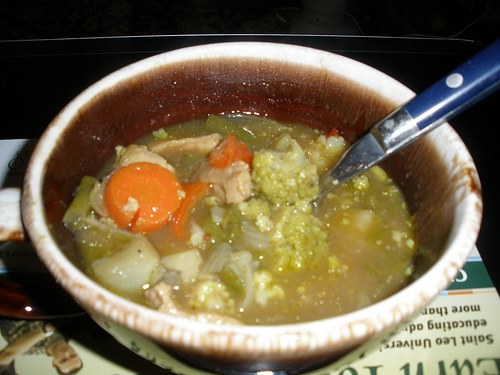If you were to write a short story about the person who made this soup, what would it be about? The person who made this soup is a kind-hearted grandmother who loves to cook for her family. She spends her mornings in the garden picking fresh vegetables and then spends her afternoons in the kitchen, filling the house with the aromas of her delicious homemade meals. The soup simmering on the stove is just one example of her love and care, poured into every meal she prepares. 